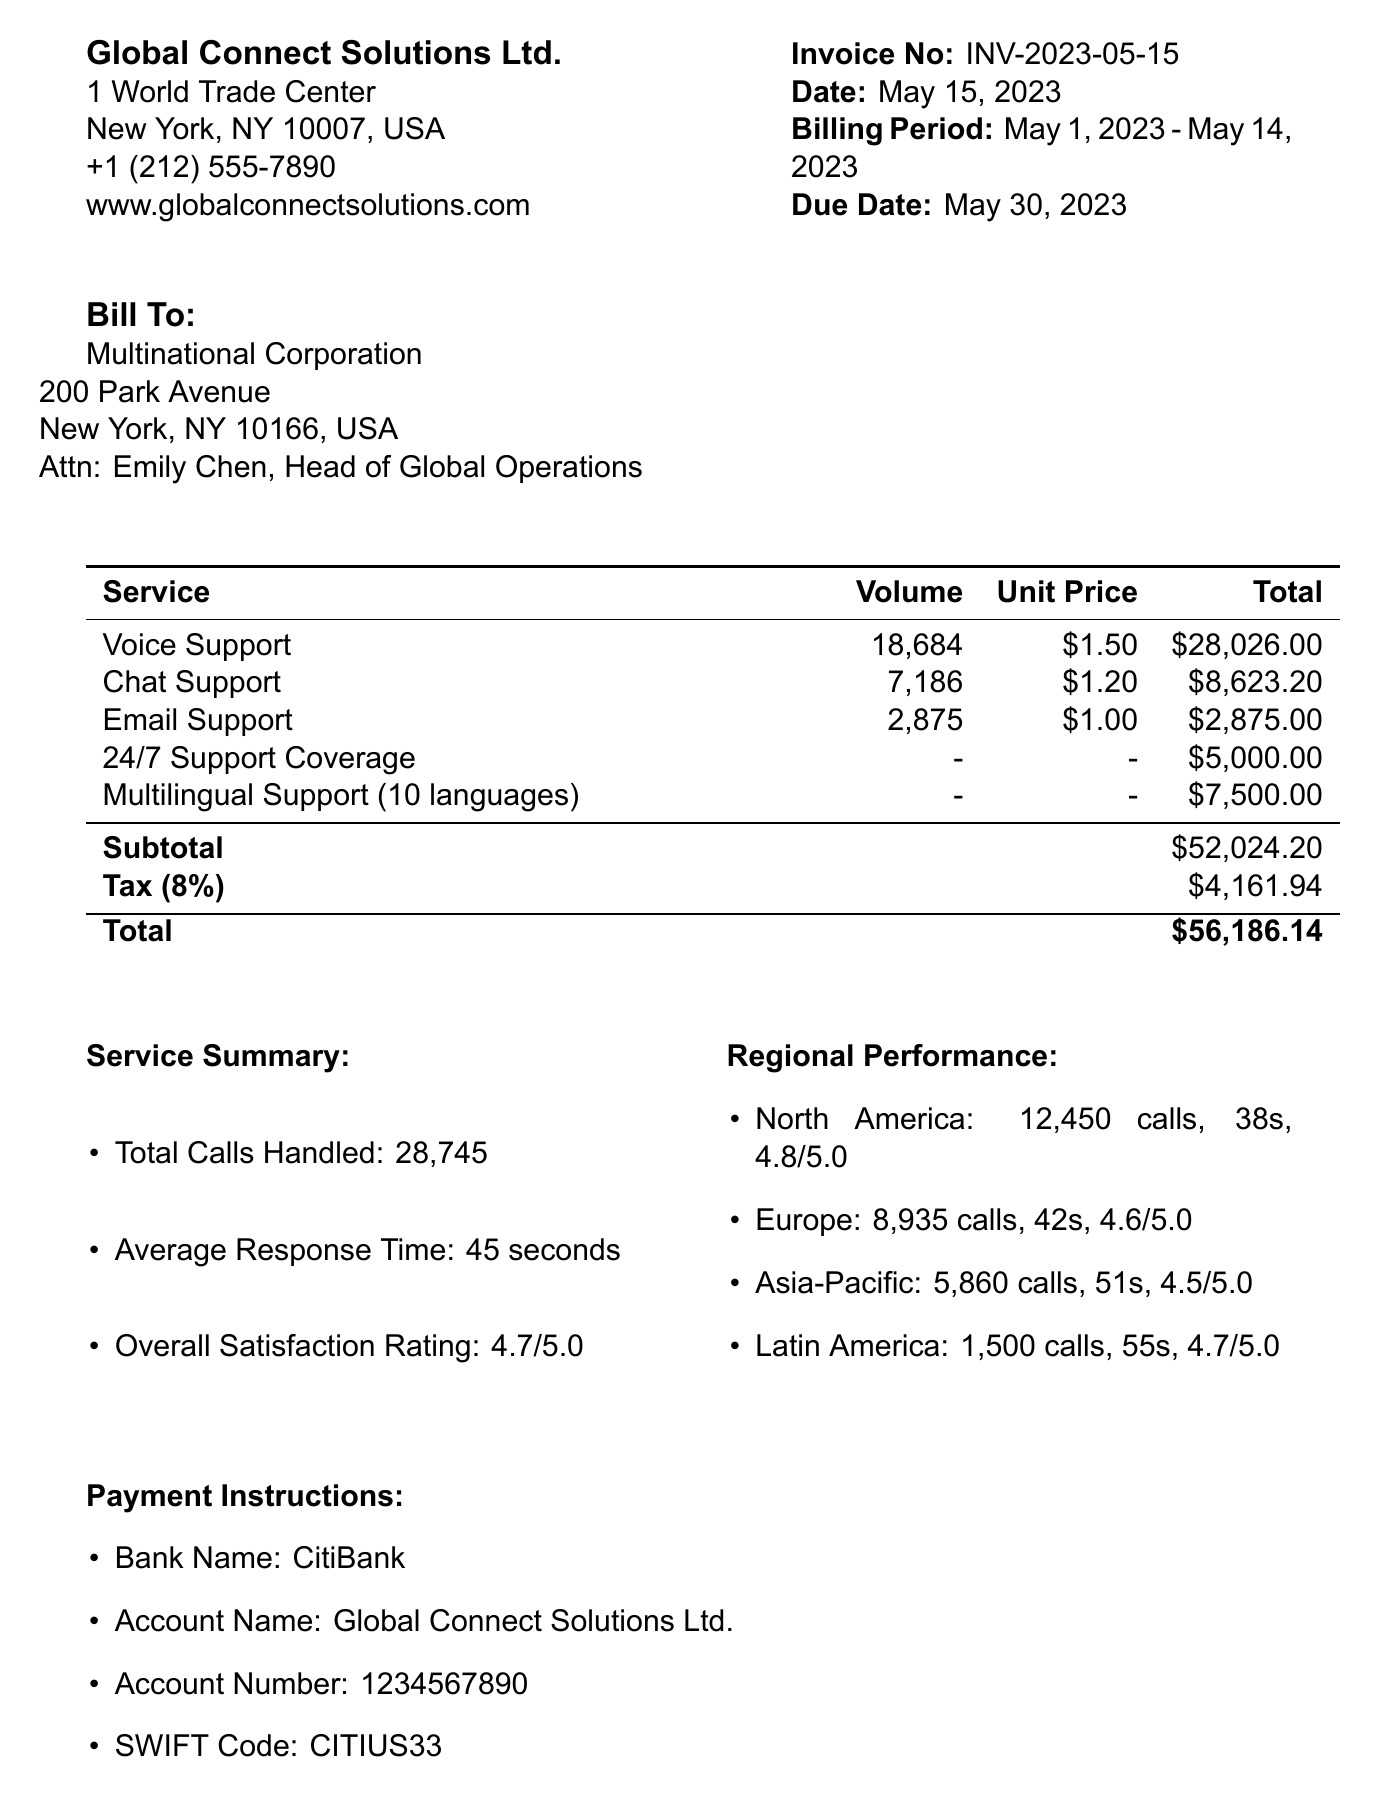What is the invoice number? The invoice number is specified in the invoice details section of the document.
Answer: INV-2023-05-15 What is the total amount due? The total amount due is summarized at the end of the invoice, which includes subtotal, tax, and total.
Answer: $56,186.14 How many calls were handled in North America? The call volume for North America is provided in the regional performance section of the document.
Answer: 12,450 What is the average response time for the customer support services? The average response time is summarized in the service summary section of the document.
Answer: 45 seconds What is the satisfaction rating for Europe? The satisfaction rating for Europe can be found in the regional performance section of the document.
Answer: 4.6 Which service had the highest volume? The service with the highest volume is listed in the service breakdown section of the document.
Answer: Voice Support What payment method is specified in the payment instructions? The payment method is stated in the payment instructions section of the invoice.
Answer: Bank Transfer How long is the payment period before late fees apply? The payment period is mentioned in the terms and conditions section of the document.
Answer: 15 days What additional service provides support in multiple languages? This additional service is outlined in the additional services section of the document.
Answer: Multilingual Support (10 languages) 